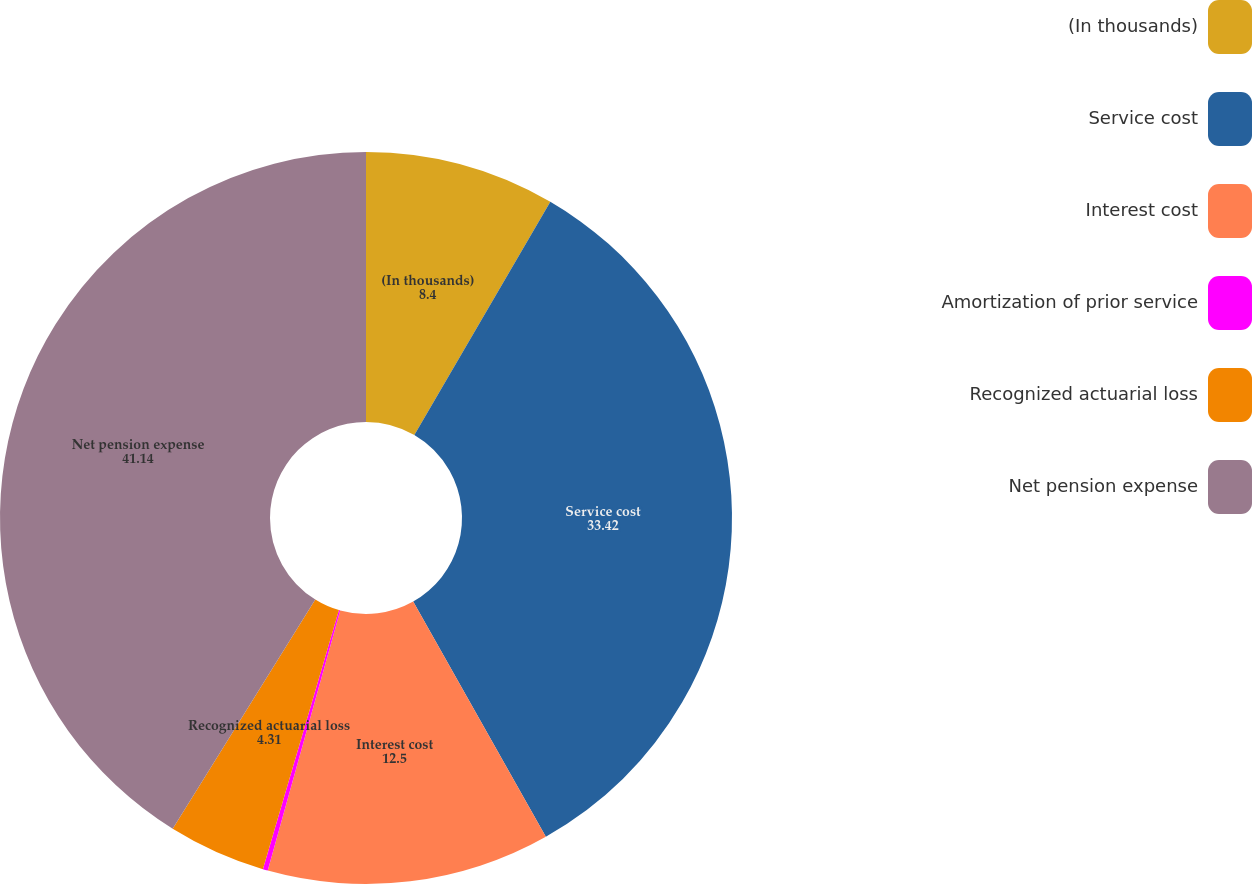<chart> <loc_0><loc_0><loc_500><loc_500><pie_chart><fcel>(In thousands)<fcel>Service cost<fcel>Interest cost<fcel>Amortization of prior service<fcel>Recognized actuarial loss<fcel>Net pension expense<nl><fcel>8.4%<fcel>33.42%<fcel>12.5%<fcel>0.22%<fcel>4.31%<fcel>41.14%<nl></chart> 